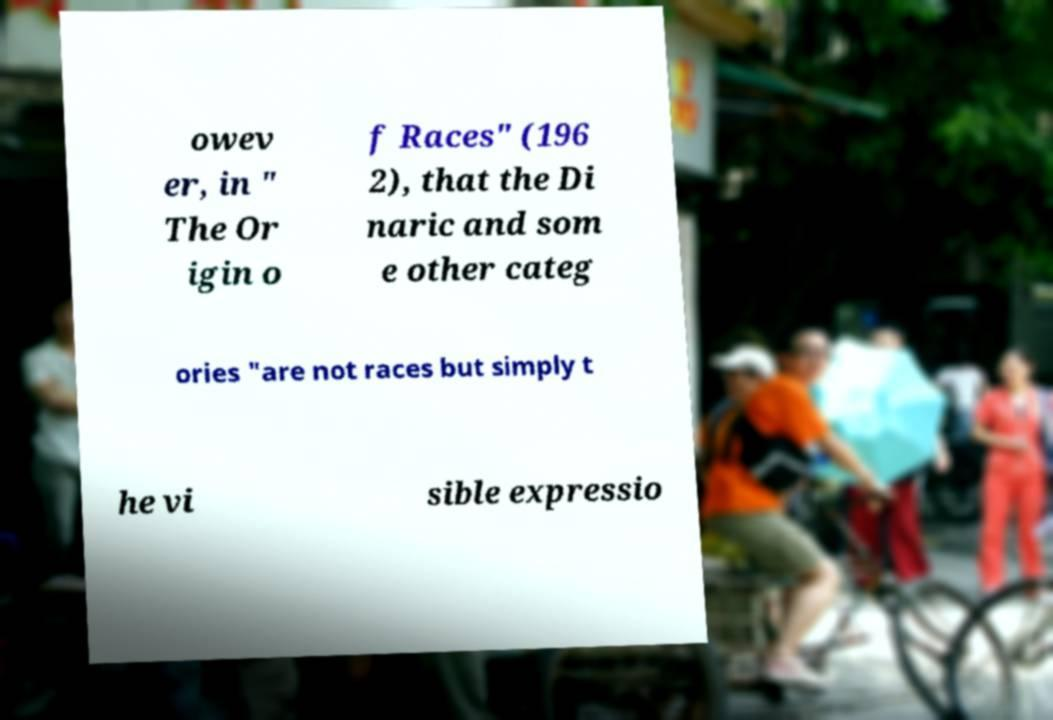Please identify and transcribe the text found in this image. owev er, in " The Or igin o f Races" (196 2), that the Di naric and som e other categ ories "are not races but simply t he vi sible expressio 